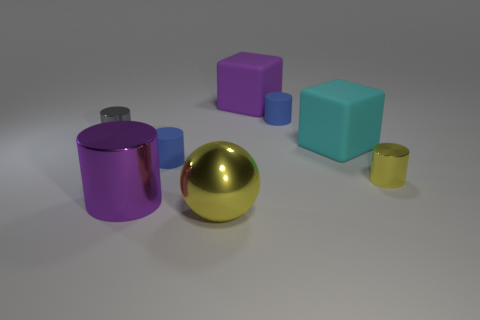Subtract all purple cylinders. How many cylinders are left? 4 Subtract all large cylinders. How many cylinders are left? 4 Subtract all red cylinders. Subtract all brown balls. How many cylinders are left? 5 Add 2 blue metallic spheres. How many objects exist? 10 Subtract all cubes. How many objects are left? 6 Add 5 small things. How many small things exist? 9 Subtract 1 purple cylinders. How many objects are left? 7 Subtract all large shiny balls. Subtract all big spheres. How many objects are left? 6 Add 3 tiny metallic cylinders. How many tiny metallic cylinders are left? 5 